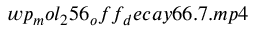<formula> <loc_0><loc_0><loc_500><loc_500>w p _ { m } o l _ { 2 } 5 6 _ { o } f f _ { d } e c a y 6 6 . 7 . m p 4</formula> 